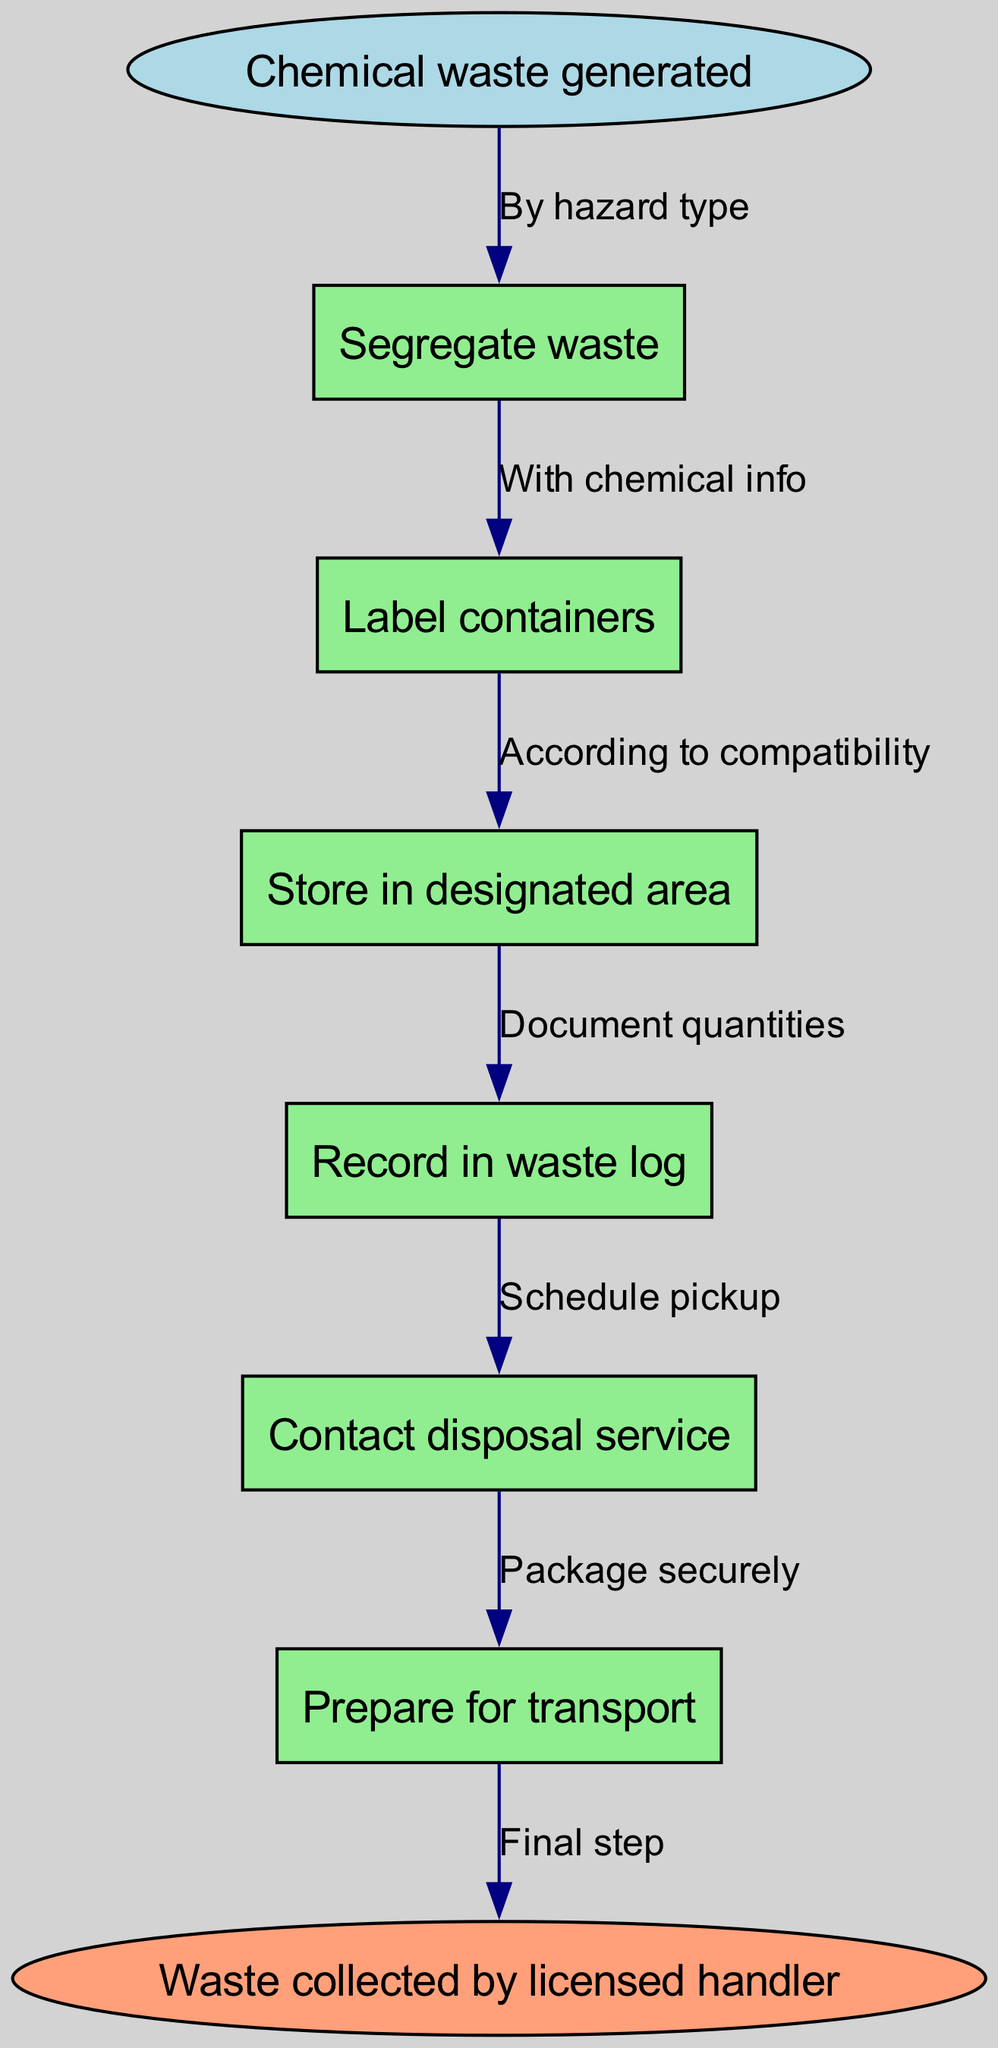What is the starting point of the chemical waste disposal process? The diagram indicates that the process begins with the "Chemical waste generated" node, which is labeled as the starting point.
Answer: Chemical waste generated How many process nodes are there in the diagram? By counting the nodes listed in the process section, there are six nodes that represent different steps in the chemical waste disposal process.
Answer: Six What is the last step in the chemical waste disposal process? The end node of the diagram states that the final step is "Waste collected by licensed handler." This indicates the conclusion of the process.
Answer: Waste collected by licensed handler What type of waste should be segregated in the process? The diagram specifies that the waste should be "By hazard type," indicating that categorization is based on the nature of the waste.
Answer: By hazard type What happens after recording in the waste log? The diagram shows that after the "Record in waste log," the next step is to "Contact disposal service," signifying that proper documentation leads to contacting the disposal service.
Answer: Contact disposal service Which step involves packaging waste? According to the diagram, the "Prepare for transport" node relates to packaging the waste securely before transport, indicating its importance in the disposal process.
Answer: Prepare for transport What is the relationship between labeling containers and the information they must contain? The flow from "Label containers" points to "With chemical info," indicating that each labeled container must include essential chemical details to ensure safe handling.
Answer: With chemical info If waste is not properly segregated, what might happen in the process? Based on the flow chart, improper segregation could hinder the efficiency of subsequent steps such as labeling and storing, potentially putting safety at risk.
Answer: Safety risk 